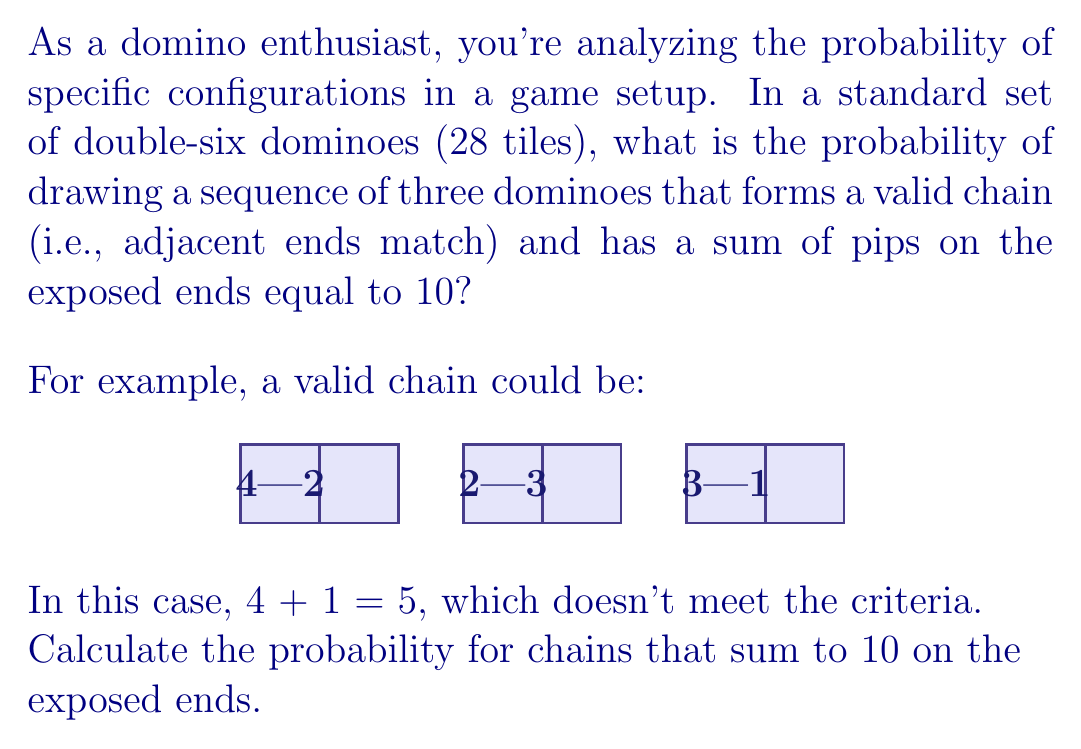Could you help me with this problem? Let's approach this step-by-step:

1) First, we need to calculate the total number of possible 3-domino sequences:
   $$ \text{Total sequences} = 28 \cdot 27 \cdot 26 = 19,656 $$

2) Now, let's consider the valid chains that sum to 10 on the exposed ends. We can represent this as:
   $$ a - b - c - d $$
   where $a + d = 10$ and $b$ and $c$ are matching numbers.

3) Possible combinations for $a$ and $d$ (considering order matters):
   (0,10), (1,9), (2,8), (3,7), (4,6), (5,5), (6,4), (7,3), (8,2), (9,1), (10,0)
   There are 11 combinations.

4) For each of these combinations, we need to consider all possible middle dominoes:
   - For (0,10) and (10,0): 6 possibilities (0-0 to 5-5)
   - For others: 7 possibilities (0-0 to 6-6)

5) Let's count the valid sequences:
   $$ (2 \cdot 6 + 9 \cdot 7) = 75 $$

6) However, each of these sequences can be drawn in 6 ways (3! = 6 permutations), so:
   $$ \text{Total valid sequences} = 75 \cdot 6 = 450 $$

7) Therefore, the probability is:
   $$ P(\text{valid chain}) = \frac{450}{19,656} = \frac{225}{9,828} \approx 0.0229 $$
Answer: $\frac{225}{9,828}$ 